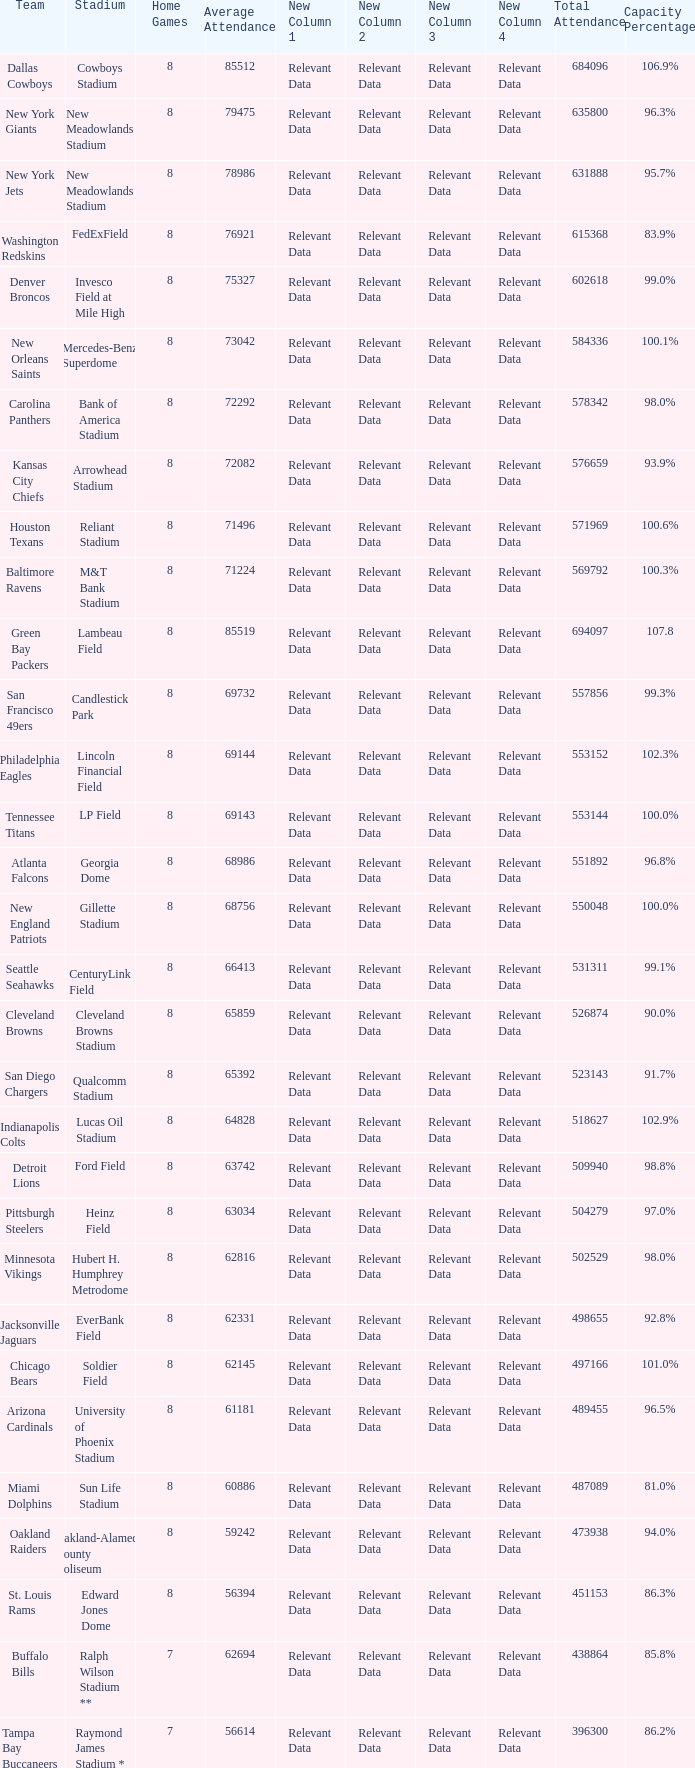How many average attendance has a capacity percentage of 96.5% 1.0. Could you parse the entire table as a dict? {'header': ['Team', 'Stadium', 'Home Games', 'Average Attendance', 'New Column 1', 'New Column 2', 'New Column 3', 'New Column 4', 'Total Attendance', 'Capacity Percentage'], 'rows': [['Dallas Cowboys', 'Cowboys Stadium', '8', '85512', 'Relevant Data', 'Relevant Data', 'Relevant Data', 'Relevant Data', '684096', '106.9%'], ['New York Giants', 'New Meadowlands Stadium', '8', '79475', 'Relevant Data', 'Relevant Data', 'Relevant Data', 'Relevant Data', '635800', '96.3%'], ['New York Jets', 'New Meadowlands Stadium', '8', '78986', 'Relevant Data', 'Relevant Data', 'Relevant Data', 'Relevant Data', '631888', '95.7%'], ['Washington Redskins', 'FedExField', '8', '76921', 'Relevant Data', 'Relevant Data', 'Relevant Data', 'Relevant Data', '615368', '83.9%'], ['Denver Broncos', 'Invesco Field at Mile High', '8', '75327', 'Relevant Data', 'Relevant Data', 'Relevant Data', 'Relevant Data', '602618', '99.0%'], ['New Orleans Saints', 'Mercedes-Benz Superdome', '8', '73042', 'Relevant Data', 'Relevant Data', 'Relevant Data', 'Relevant Data', '584336', '100.1%'], ['Carolina Panthers', 'Bank of America Stadium', '8', '72292', 'Relevant Data', 'Relevant Data', 'Relevant Data', 'Relevant Data', '578342', '98.0%'], ['Kansas City Chiefs', 'Arrowhead Stadium', '8', '72082', 'Relevant Data', 'Relevant Data', 'Relevant Data', 'Relevant Data', '576659', '93.9%'], ['Houston Texans', 'Reliant Stadium', '8', '71496', 'Relevant Data', 'Relevant Data', 'Relevant Data', 'Relevant Data', '571969', '100.6%'], ['Baltimore Ravens', 'M&T Bank Stadium', '8', '71224', 'Relevant Data', 'Relevant Data', 'Relevant Data', 'Relevant Data', '569792', '100.3%'], ['Green Bay Packers', 'Lambeau Field', '8', '85519', 'Relevant Data', 'Relevant Data', 'Relevant Data', 'Relevant Data', '694097', '107.8'], ['San Francisco 49ers', 'Candlestick Park', '8', '69732', 'Relevant Data', 'Relevant Data', 'Relevant Data', 'Relevant Data', '557856', '99.3%'], ['Philadelphia Eagles', 'Lincoln Financial Field', '8', '69144', 'Relevant Data', 'Relevant Data', 'Relevant Data', 'Relevant Data', '553152', '102.3%'], ['Tennessee Titans', 'LP Field', '8', '69143', 'Relevant Data', 'Relevant Data', 'Relevant Data', 'Relevant Data', '553144', '100.0%'], ['Atlanta Falcons', 'Georgia Dome', '8', '68986', 'Relevant Data', 'Relevant Data', 'Relevant Data', 'Relevant Data', '551892', '96.8%'], ['New England Patriots', 'Gillette Stadium', '8', '68756', 'Relevant Data', 'Relevant Data', 'Relevant Data', 'Relevant Data', '550048', '100.0%'], ['Seattle Seahawks', 'CenturyLink Field', '8', '66413', 'Relevant Data', 'Relevant Data', 'Relevant Data', 'Relevant Data', '531311', '99.1%'], ['Cleveland Browns', 'Cleveland Browns Stadium', '8', '65859', 'Relevant Data', 'Relevant Data', 'Relevant Data', 'Relevant Data', '526874', '90.0%'], ['San Diego Chargers', 'Qualcomm Stadium', '8', '65392', 'Relevant Data', 'Relevant Data', 'Relevant Data', 'Relevant Data', '523143', '91.7%'], ['Indianapolis Colts', 'Lucas Oil Stadium', '8', '64828', 'Relevant Data', 'Relevant Data', 'Relevant Data', 'Relevant Data', '518627', '102.9%'], ['Detroit Lions', 'Ford Field', '8', '63742', 'Relevant Data', 'Relevant Data', 'Relevant Data', 'Relevant Data', '509940', '98.8%'], ['Pittsburgh Steelers', 'Heinz Field', '8', '63034', 'Relevant Data', 'Relevant Data', 'Relevant Data', 'Relevant Data', '504279', '97.0%'], ['Minnesota Vikings', 'Hubert H. Humphrey Metrodome', '8', '62816', 'Relevant Data', 'Relevant Data', 'Relevant Data', 'Relevant Data', '502529', '98.0%'], ['Jacksonville Jaguars', 'EverBank Field', '8', '62331', 'Relevant Data', 'Relevant Data', 'Relevant Data', 'Relevant Data', '498655', '92.8%'], ['Chicago Bears', 'Soldier Field', '8', '62145', 'Relevant Data', 'Relevant Data', 'Relevant Data', 'Relevant Data', '497166', '101.0%'], ['Arizona Cardinals', 'University of Phoenix Stadium', '8', '61181', 'Relevant Data', 'Relevant Data', 'Relevant Data', 'Relevant Data', '489455', '96.5%'], ['Miami Dolphins', 'Sun Life Stadium', '8', '60886', 'Relevant Data', 'Relevant Data', 'Relevant Data', 'Relevant Data', '487089', '81.0%'], ['Oakland Raiders', 'Oakland-Alameda County Coliseum', '8', '59242', 'Relevant Data', 'Relevant Data', 'Relevant Data', 'Relevant Data', '473938', '94.0%'], ['St. Louis Rams', 'Edward Jones Dome', '8', '56394', 'Relevant Data', 'Relevant Data', 'Relevant Data', 'Relevant Data', '451153', '86.3%'], ['Buffalo Bills', 'Ralph Wilson Stadium **', '7', '62694', 'Relevant Data', 'Relevant Data', 'Relevant Data', 'Relevant Data', '438864', '85.8%'], ['Tampa Bay Buccaneers', 'Raymond James Stadium *', '7', '56614', 'Relevant Data', 'Relevant Data', 'Relevant Data', 'Relevant Data', '396300', '86.2%']]} 